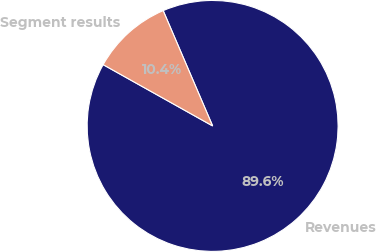Convert chart to OTSL. <chart><loc_0><loc_0><loc_500><loc_500><pie_chart><fcel>Revenues<fcel>Segment results<nl><fcel>89.57%<fcel>10.43%<nl></chart> 